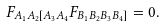Convert formula to latex. <formula><loc_0><loc_0><loc_500><loc_500>F _ { A _ { 1 } A _ { 2 } [ A _ { 3 } A _ { 4 } } F _ { B _ { 1 } B _ { 2 } B _ { 3 } B _ { 4 } ] } = 0 .</formula> 